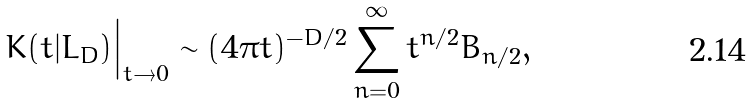Convert formula to latex. <formula><loc_0><loc_0><loc_500><loc_500>\Big . K ( t | L _ { D } ) \Big | _ { t \to 0 } \sim ( 4 \pi t ) ^ { - D / 2 } \sum _ { n = 0 } ^ { \infty } t ^ { n / 2 } B _ { n / 2 } ,</formula> 